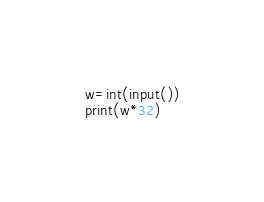<code> <loc_0><loc_0><loc_500><loc_500><_Python_>w=int(input())
print(w*32)
</code> 